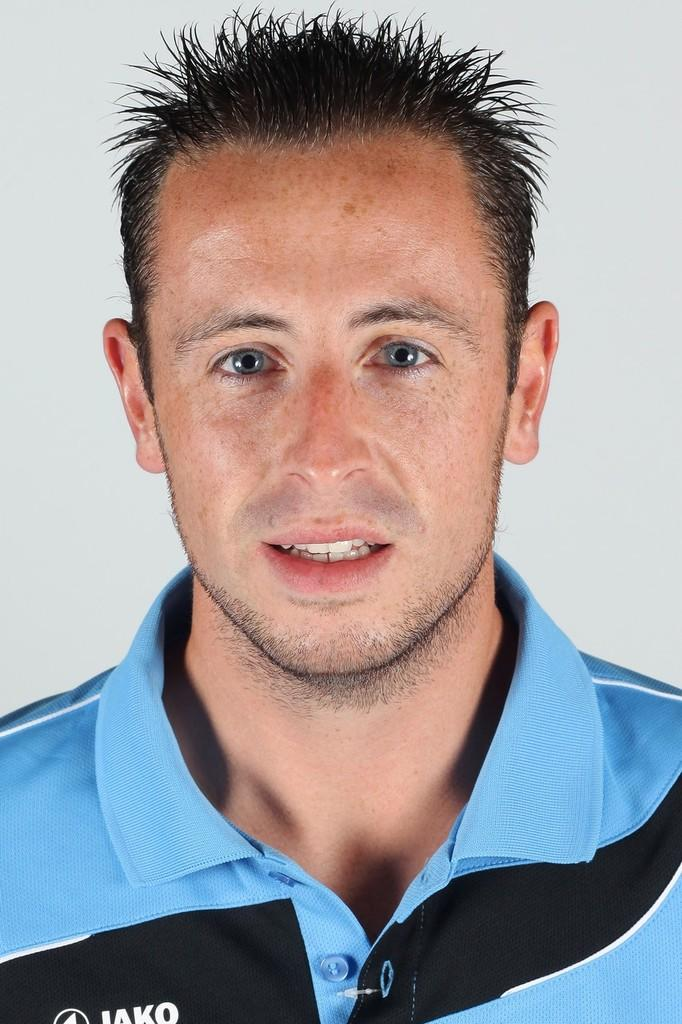Who is present in the image? There is a man in the image. What is the man wearing? The man is wearing a blue and black t-shirt. What color is the background of the image? The background of the image is off white. What can be seen on the man's t-shirt? There is text on the man's t-shirt. What type of oven is visible in the image? There is no oven present in the image. What is the man doing with the engine in the image? There is no engine present in the image, and the man's actions are not described in the facts. 